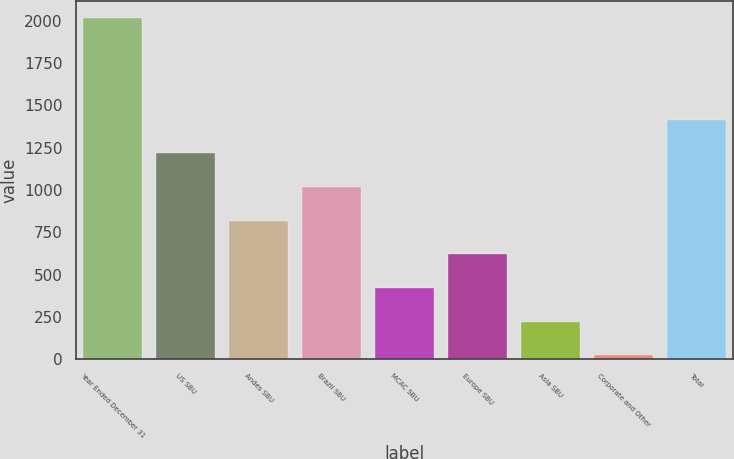<chart> <loc_0><loc_0><loc_500><loc_500><bar_chart><fcel>Year Ended December 31<fcel>US SBU<fcel>Andes SBU<fcel>Brazil SBU<fcel>MCAC SBU<fcel>Europe SBU<fcel>Asia SBU<fcel>Corporate and Other<fcel>Total<nl><fcel>2014<fcel>1218<fcel>820<fcel>1019<fcel>422<fcel>621<fcel>223<fcel>24<fcel>1417<nl></chart> 